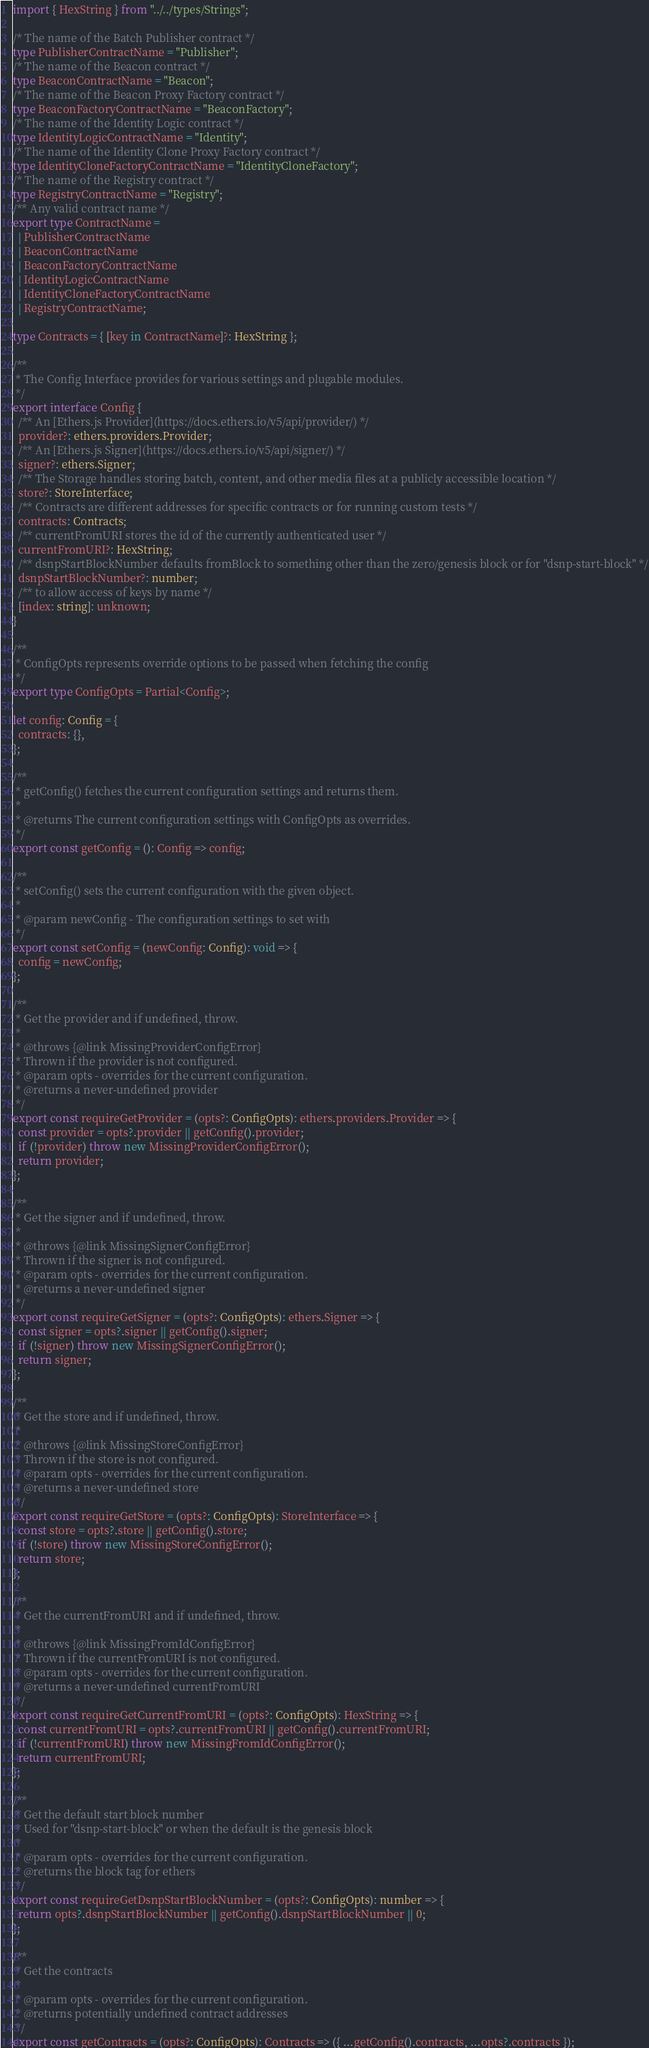<code> <loc_0><loc_0><loc_500><loc_500><_TypeScript_>import { HexString } from "../../types/Strings";

/* The name of the Batch Publisher contract */
type PublisherContractName = "Publisher";
/* The name of the Beacon contract */
type BeaconContractName = "Beacon";
/* The name of the Beacon Proxy Factory contract */
type BeaconFactoryContractName = "BeaconFactory";
/* The name of the Identity Logic contract */
type IdentityLogicContractName = "Identity";
/* The name of the Identity Clone Proxy Factory contract */
type IdentityCloneFactoryContractName = "IdentityCloneFactory";
/* The name of the Registry contract */
type RegistryContractName = "Registry";
/** Any valid contract name */
export type ContractName =
  | PublisherContractName
  | BeaconContractName
  | BeaconFactoryContractName
  | IdentityLogicContractName
  | IdentityCloneFactoryContractName
  | RegistryContractName;

type Contracts = { [key in ContractName]?: HexString };

/**
 * The Config Interface provides for various settings and plugable modules.
 */
export interface Config {
  /** An [Ethers.js Provider](https://docs.ethers.io/v5/api/provider/) */
  provider?: ethers.providers.Provider;
  /** An [Ethers.js Signer](https://docs.ethers.io/v5/api/signer/) */
  signer?: ethers.Signer;
  /** The Storage handles storing batch, content, and other media files at a publicly accessible location */
  store?: StoreInterface;
  /** Contracts are different addresses for specific contracts or for running custom tests */
  contracts: Contracts;
  /** currentFromURI stores the id of the currently authenticated user */
  currentFromURI?: HexString;
  /** dsnpStartBlockNumber defaults fromBlock to something other than the zero/genesis block or for "dsnp-start-block" */
  dsnpStartBlockNumber?: number;
  /** to allow access of keys by name */
  [index: string]: unknown;
}

/**
 * ConfigOpts represents override options to be passed when fetching the config
 */
export type ConfigOpts = Partial<Config>;

let config: Config = {
  contracts: {},
};

/**
 * getConfig() fetches the current configuration settings and returns them.
 *
 * @returns The current configuration settings with ConfigOpts as overrides.
 */
export const getConfig = (): Config => config;

/**
 * setConfig() sets the current configuration with the given object.
 *
 * @param newConfig - The configuration settings to set with
 */
export const setConfig = (newConfig: Config): void => {
  config = newConfig;
};

/**
 * Get the provider and if undefined, throw.
 *
 * @throws {@link MissingProviderConfigError}
 * Thrown if the provider is not configured.
 * @param opts - overrides for the current configuration.
 * @returns a never-undefined provider
 */
export const requireGetProvider = (opts?: ConfigOpts): ethers.providers.Provider => {
  const provider = opts?.provider || getConfig().provider;
  if (!provider) throw new MissingProviderConfigError();
  return provider;
};

/**
 * Get the signer and if undefined, throw.
 *
 * @throws {@link MissingSignerConfigError}
 * Thrown if the signer is not configured.
 * @param opts - overrides for the current configuration.
 * @returns a never-undefined signer
 */
export const requireGetSigner = (opts?: ConfigOpts): ethers.Signer => {
  const signer = opts?.signer || getConfig().signer;
  if (!signer) throw new MissingSignerConfigError();
  return signer;
};

/**
 * Get the store and if undefined, throw.
 *
 * @throws {@link MissingStoreConfigError}
 * Thrown if the store is not configured.
 * @param opts - overrides for the current configuration.
 * @returns a never-undefined store
 */
export const requireGetStore = (opts?: ConfigOpts): StoreInterface => {
  const store = opts?.store || getConfig().store;
  if (!store) throw new MissingStoreConfigError();
  return store;
};

/**
 * Get the currentFromURI and if undefined, throw.
 *
 * @throws {@link MissingFromIdConfigError}
 * Thrown if the currentFromURI is not configured.
 * @param opts - overrides for the current configuration.
 * @returns a never-undefined currentFromURI
 */
export const requireGetCurrentFromURI = (opts?: ConfigOpts): HexString => {
  const currentFromURI = opts?.currentFromURI || getConfig().currentFromURI;
  if (!currentFromURI) throw new MissingFromIdConfigError();
  return currentFromURI;
};

/**
 * Get the default start block number
 * Used for "dsnp-start-block" or when the default is the genesis block
 *
 * @param opts - overrides for the current configuration.
 * @returns the block tag for ethers
 */
export const requireGetDsnpStartBlockNumber = (opts?: ConfigOpts): number => {
  return opts?.dsnpStartBlockNumber || getConfig().dsnpStartBlockNumber || 0;
};

/**
 * Get the contracts
 *
 * @param opts - overrides for the current configuration.
 * @returns potentially undefined contract addresses
 */
export const getContracts = (opts?: ConfigOpts): Contracts => ({ ...getConfig().contracts, ...opts?.contracts });
</code> 